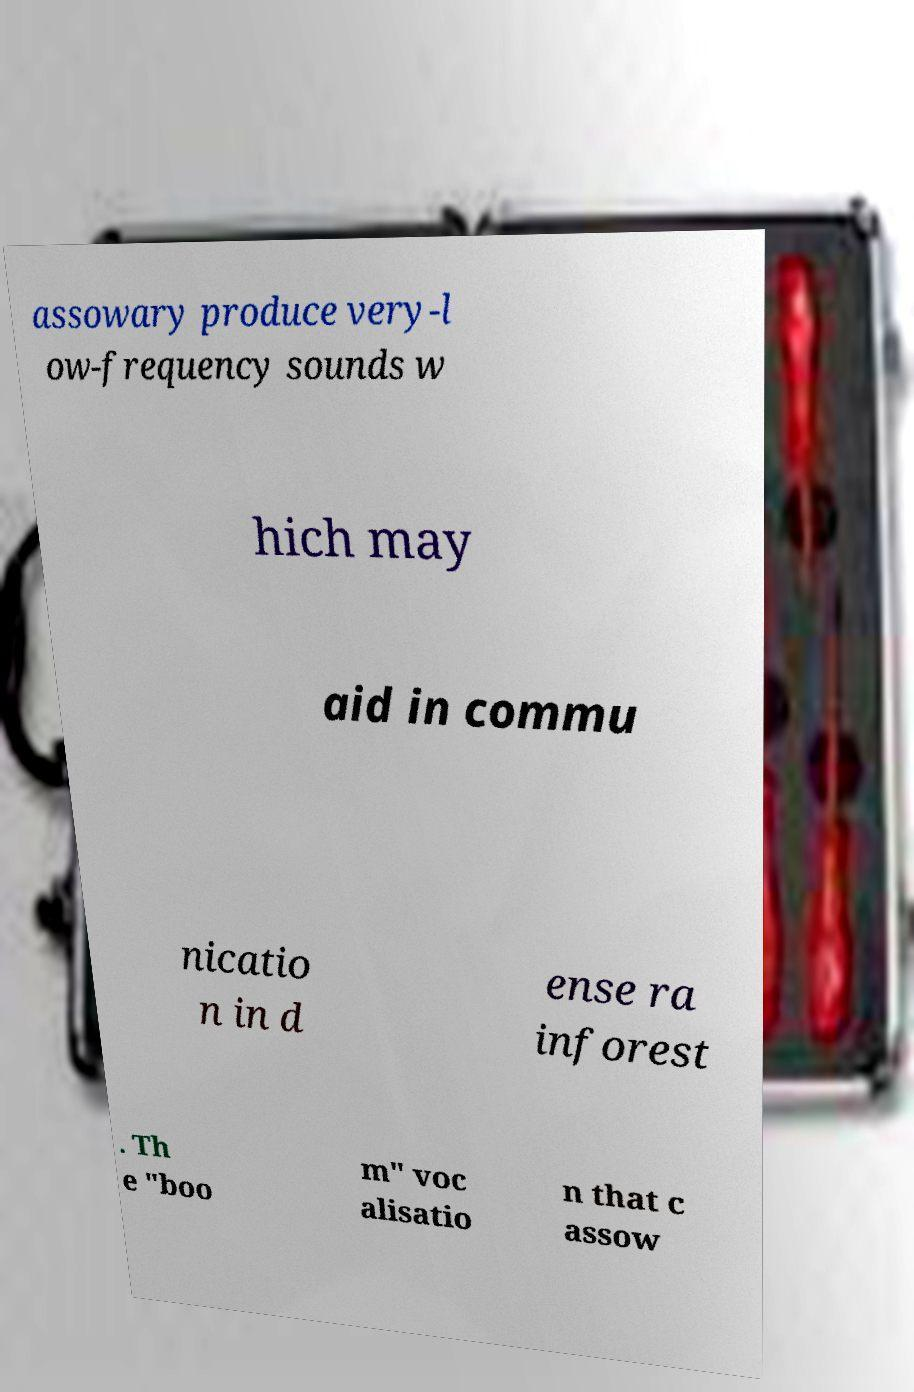Could you assist in decoding the text presented in this image and type it out clearly? assowary produce very-l ow-frequency sounds w hich may aid in commu nicatio n in d ense ra inforest . Th e "boo m" voc alisatio n that c assow 